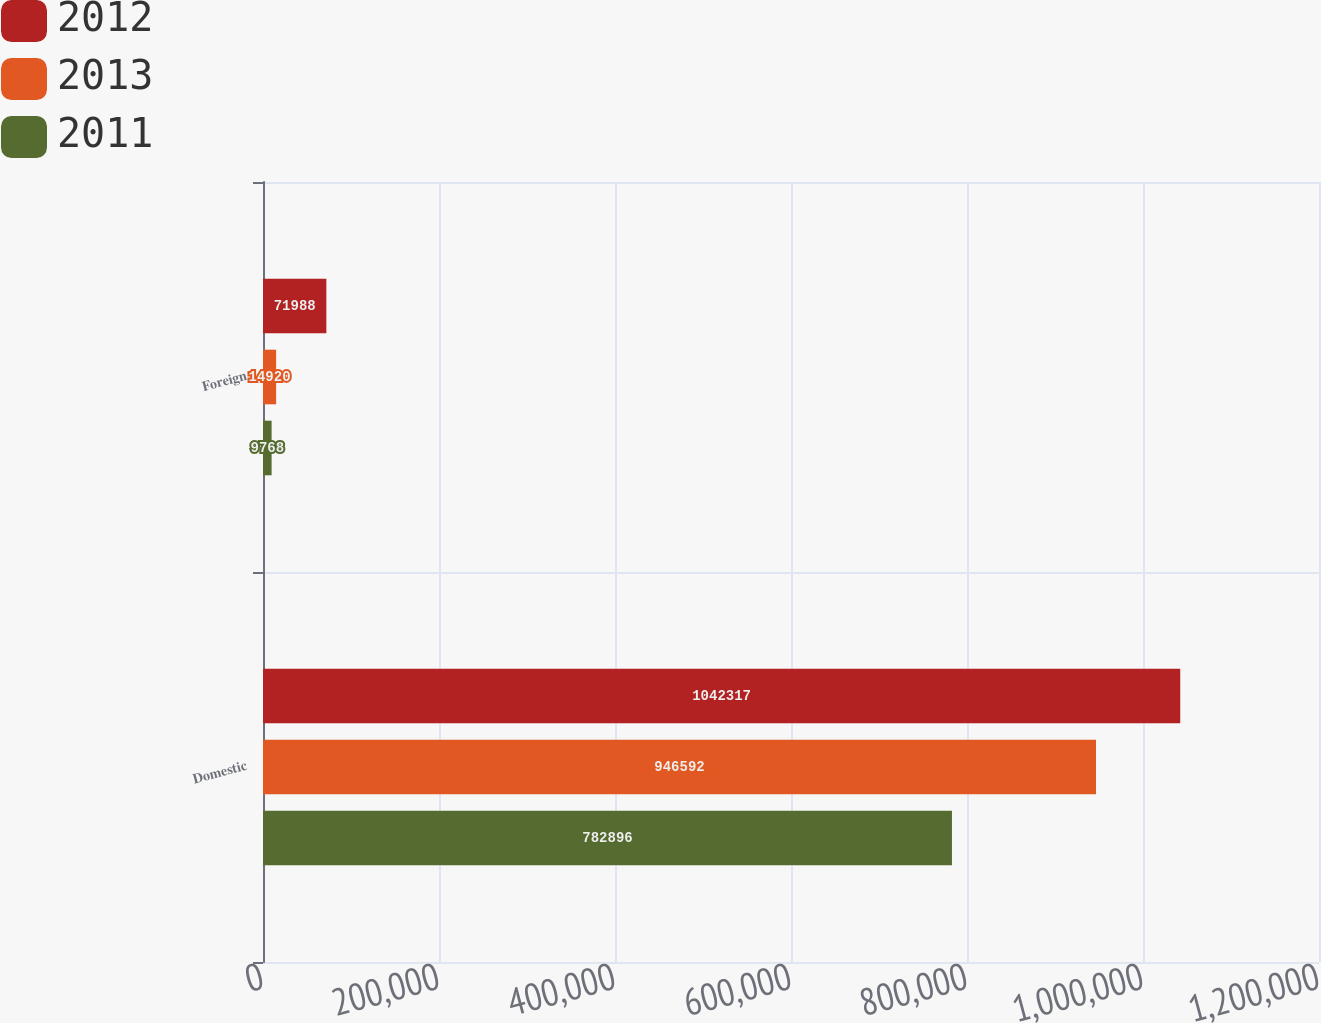<chart> <loc_0><loc_0><loc_500><loc_500><stacked_bar_chart><ecel><fcel>Domestic<fcel>Foreign<nl><fcel>2012<fcel>1.04232e+06<fcel>71988<nl><fcel>2013<fcel>946592<fcel>14920<nl><fcel>2011<fcel>782896<fcel>9768<nl></chart> 